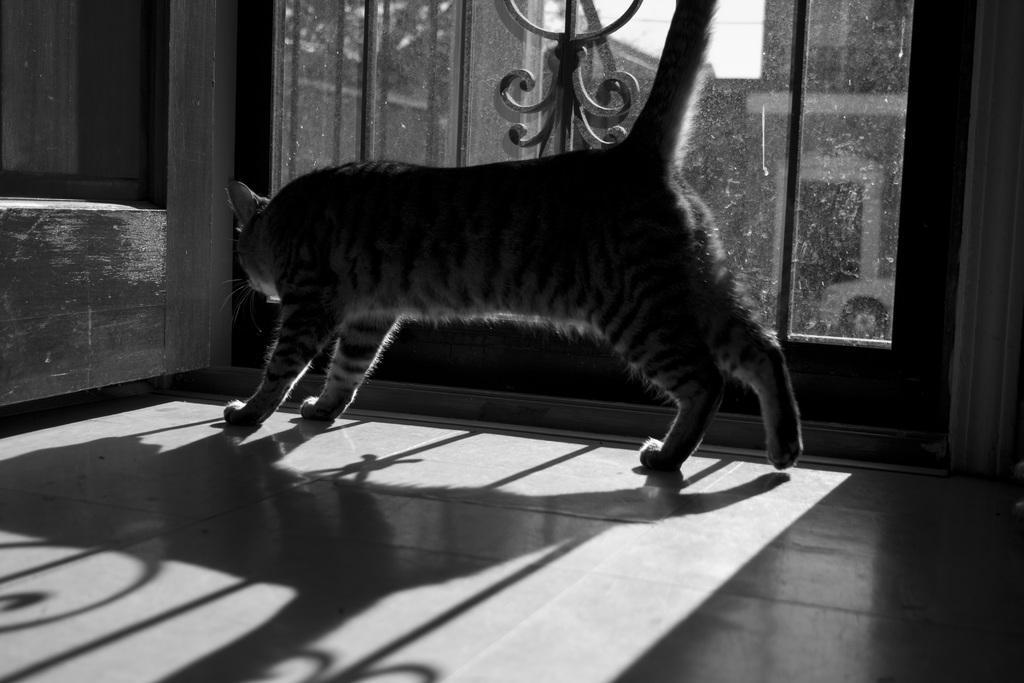In one or two sentences, can you explain what this image depicts? This is the picture of a room. In this image there is a cat standing on the floor. At the back there is a door and there are buildings and there is a car outside the door. At the top there is sky. At the bottom there is a shadow of door and cat on the floor. 